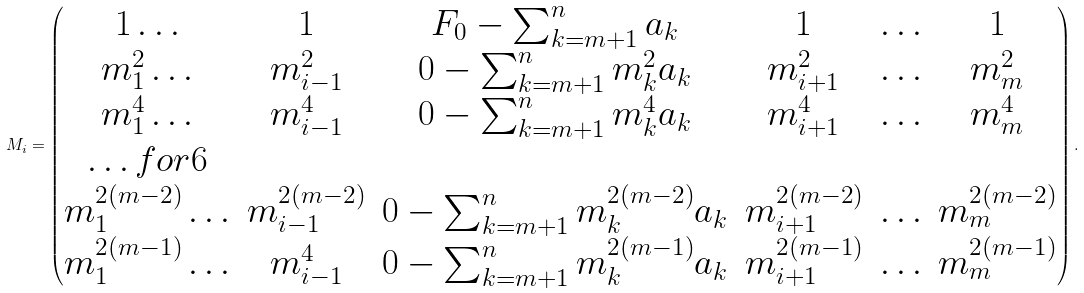Convert formula to latex. <formula><loc_0><loc_0><loc_500><loc_500>M _ { i } = \begin{pmatrix} 1 \hdots & 1 & F _ { 0 } - \sum _ { \substack { k = m + 1 } } ^ { n } a _ { k } & 1 & \hdots & 1 \\ m _ { 1 } ^ { 2 } \hdots & m _ { i - 1 } ^ { 2 } & 0 - \sum _ { \substack { k = m + 1 } } ^ { n } m _ { k } ^ { 2 } a _ { k } & m _ { i + 1 } ^ { 2 } & \hdots & m _ { m } ^ { 2 } \\ m _ { 1 } ^ { 4 } \hdots & m _ { i - 1 } ^ { 4 } & 0 - \sum _ { \substack { k = m + 1 } } ^ { n } m _ { k } ^ { 4 } a _ { k } & m _ { i + 1 } ^ { 4 } & \hdots & m _ { m } ^ { 4 } \\ \hdots f o r 6 \\ m _ { 1 } ^ { 2 ( m - 2 ) } \hdots & m _ { i - 1 } ^ { 2 ( m - 2 ) } & 0 - \sum _ { \substack { k = m + 1 } } ^ { n } m _ { k } ^ { 2 ( m - 2 ) } a _ { k } & m _ { i + 1 } ^ { 2 ( m - 2 ) } & \hdots & m _ { m } ^ { 2 ( m - 2 ) } \\ m _ { 1 } ^ { 2 ( m - 1 ) } \hdots & m _ { i - 1 } ^ { 4 } & 0 - \sum _ { \substack { k = m + 1 } } ^ { n } m _ { k } ^ { 2 ( m - 1 ) } a _ { k } & m _ { i + 1 } ^ { 2 ( m - 1 ) } & \hdots & m _ { m } ^ { 2 ( m - 1 ) } \\ \end{pmatrix} .</formula> 